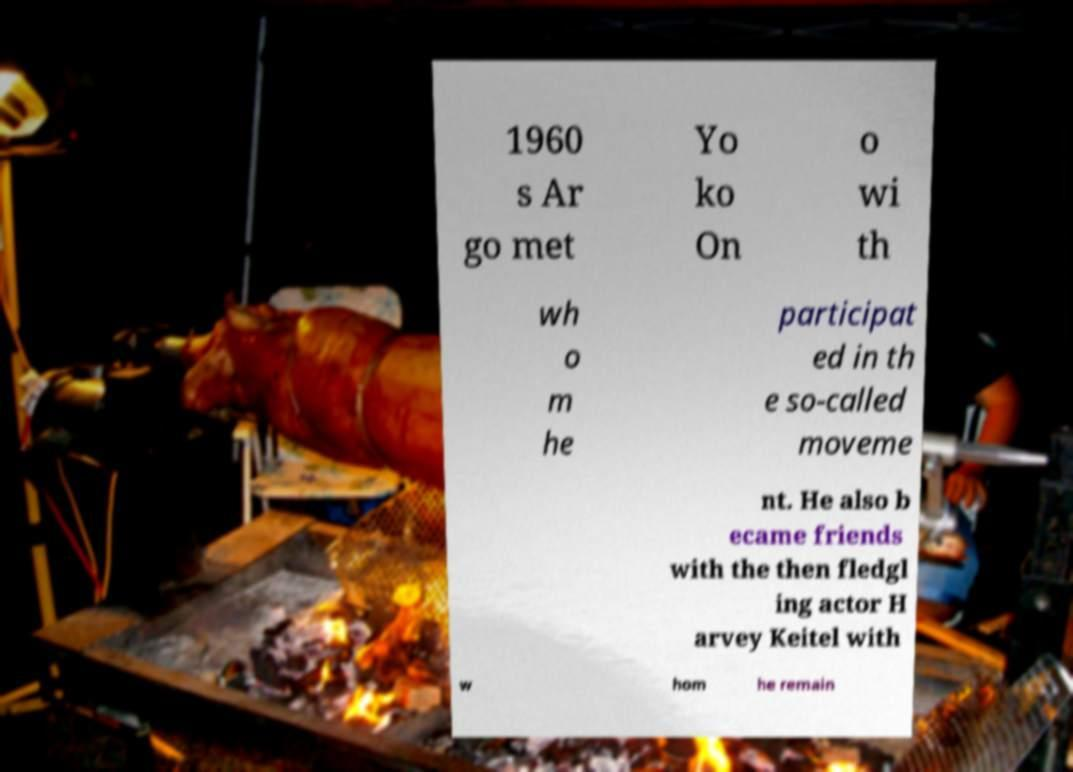I need the written content from this picture converted into text. Can you do that? 1960 s Ar go met Yo ko On o wi th wh o m he participat ed in th e so-called moveme nt. He also b ecame friends with the then fledgl ing actor H arvey Keitel with w hom he remain 